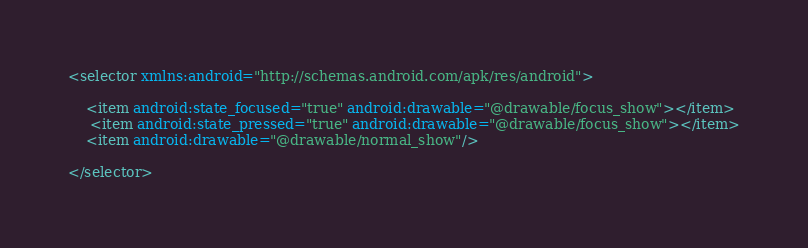Convert code to text. <code><loc_0><loc_0><loc_500><loc_500><_XML_><selector xmlns:android="http://schemas.android.com/apk/res/android">

    <item android:state_focused="true" android:drawable="@drawable/focus_show"></item>
     <item android:state_pressed="true" android:drawable="@drawable/focus_show"></item>
    <item android:drawable="@drawable/normal_show"/>

</selector></code> 